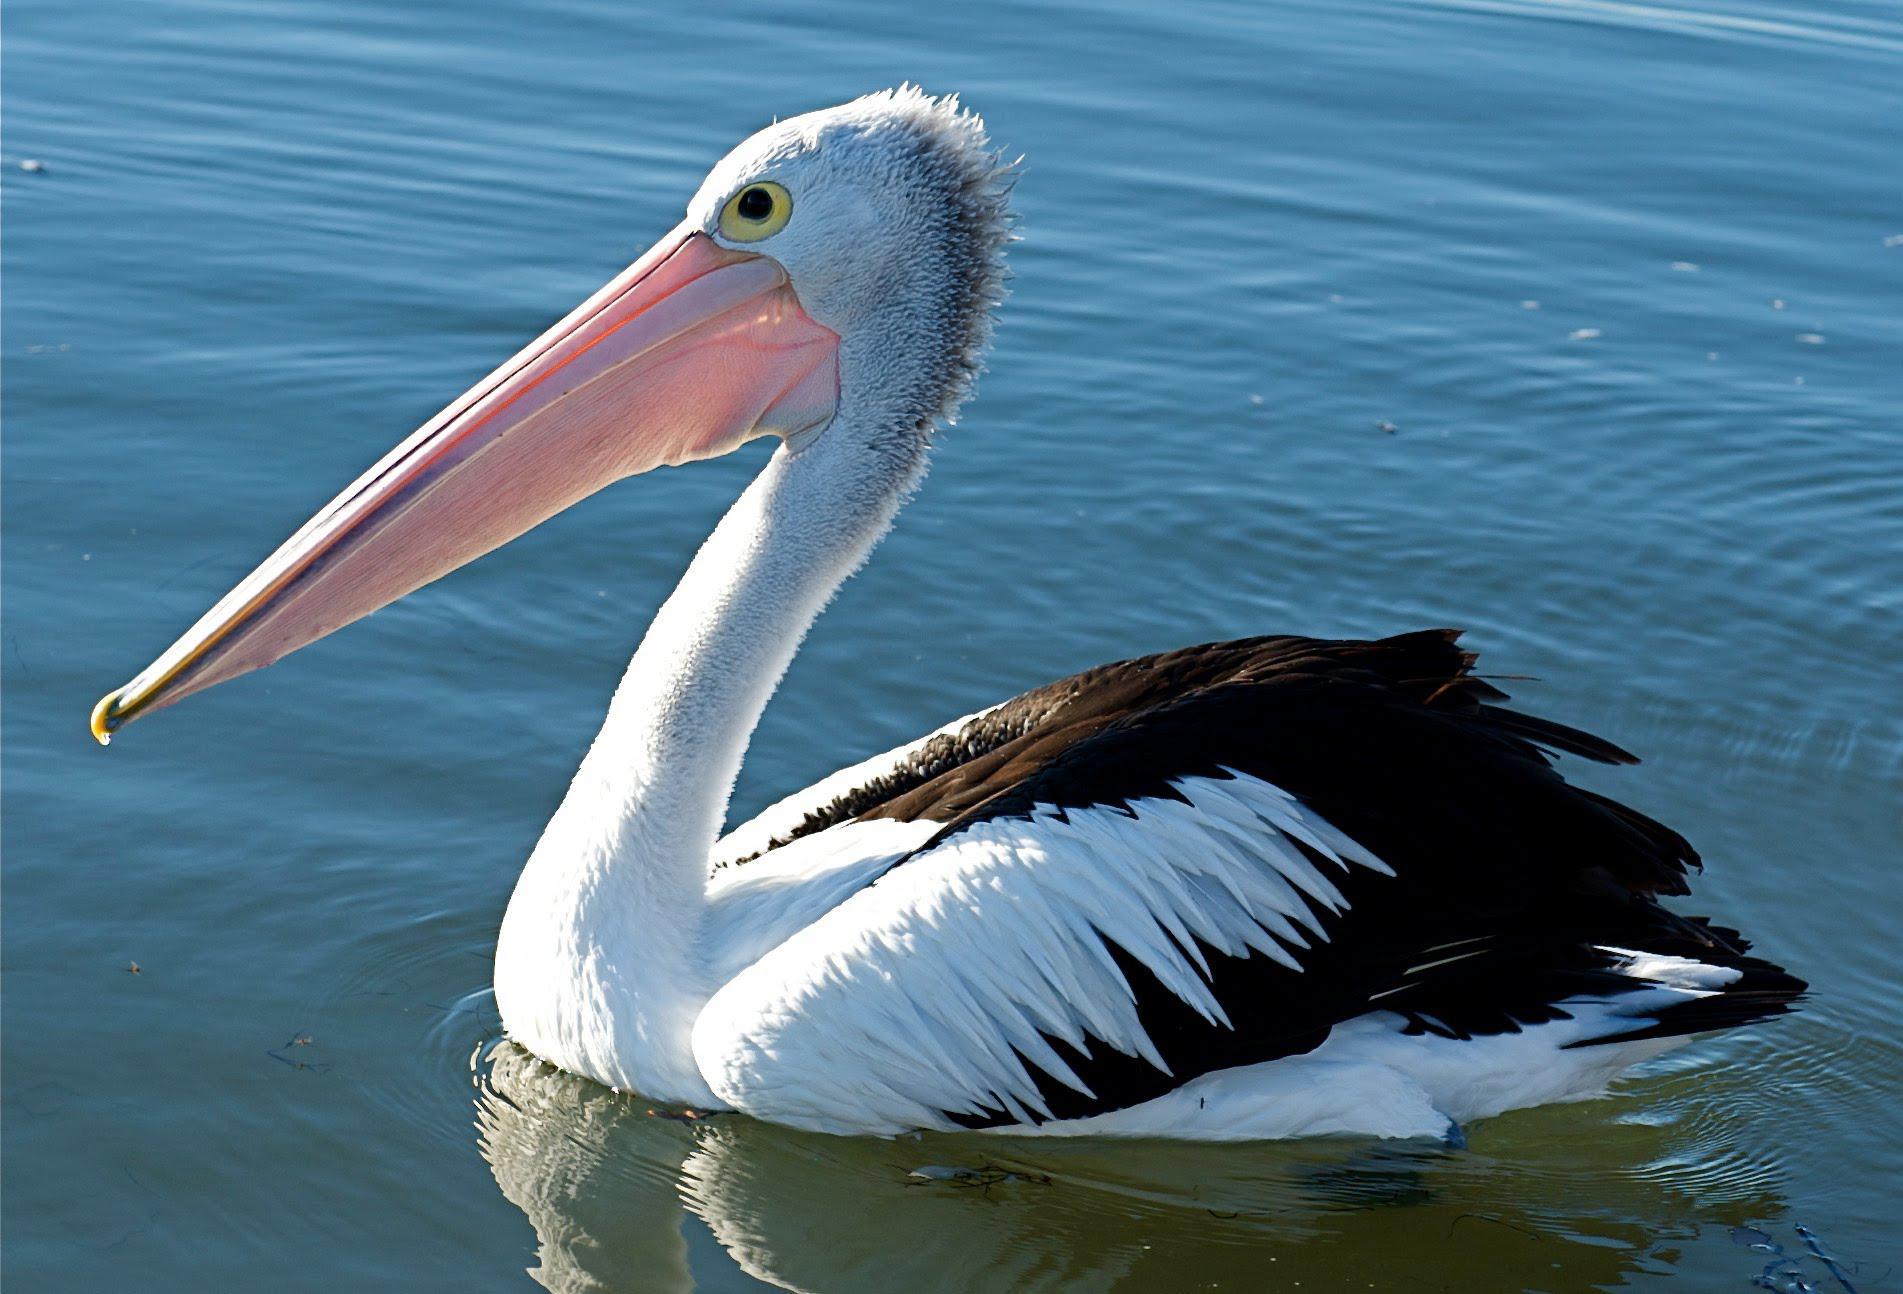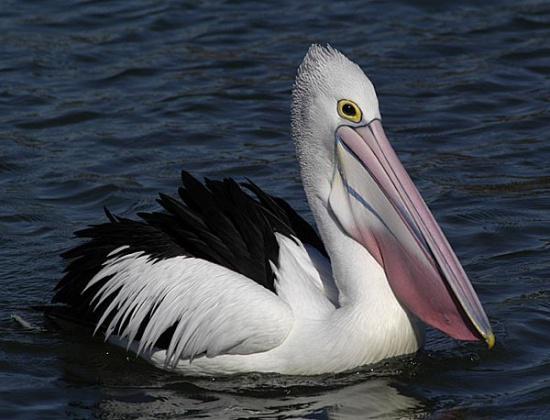The first image is the image on the left, the second image is the image on the right. For the images shown, is this caption "One image includes a pelican with it's beak open wide." true? Answer yes or no. No. The first image is the image on the left, the second image is the image on the right. For the images displayed, is the sentence "One of the pelicans is flying." factually correct? Answer yes or no. No. 